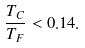<formula> <loc_0><loc_0><loc_500><loc_500>\frac { T _ { C } } { T _ { F } } < 0 . 1 4 .</formula> 